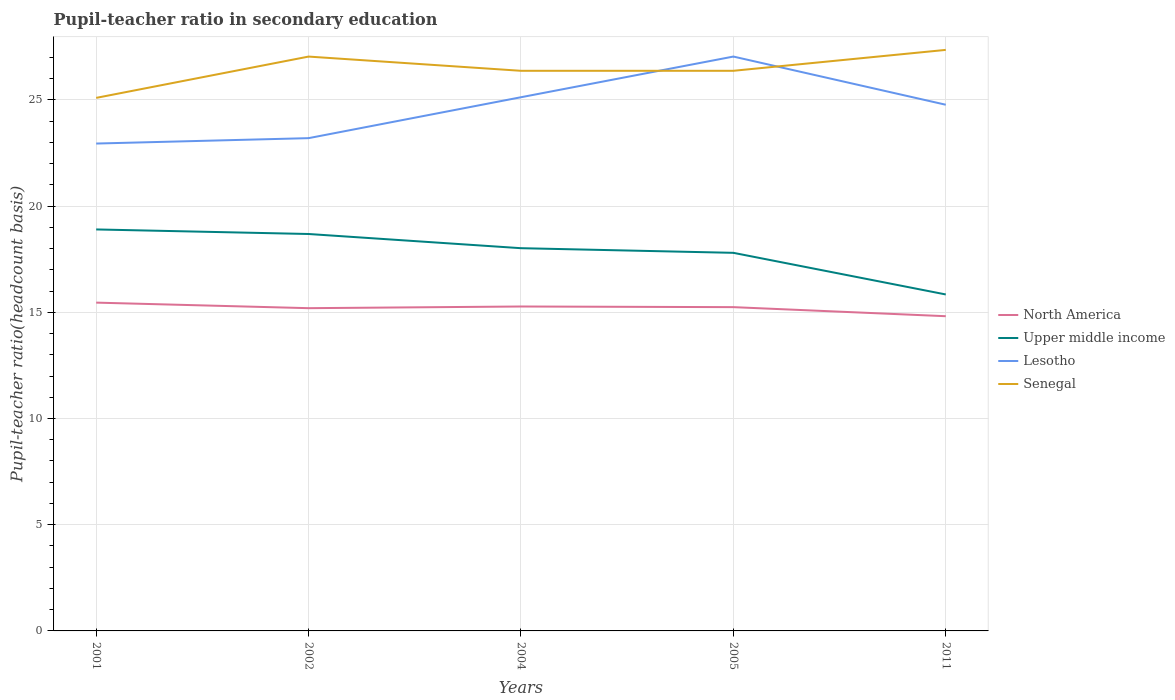How many different coloured lines are there?
Make the answer very short. 4. Is the number of lines equal to the number of legend labels?
Give a very brief answer. Yes. Across all years, what is the maximum pupil-teacher ratio in secondary education in Lesotho?
Provide a short and direct response. 22.94. What is the total pupil-teacher ratio in secondary education in Senegal in the graph?
Give a very brief answer. -0. What is the difference between the highest and the second highest pupil-teacher ratio in secondary education in North America?
Your answer should be compact. 0.64. Is the pupil-teacher ratio in secondary education in Upper middle income strictly greater than the pupil-teacher ratio in secondary education in North America over the years?
Ensure brevity in your answer.  No. How many lines are there?
Offer a terse response. 4. How many years are there in the graph?
Your answer should be very brief. 5. What is the difference between two consecutive major ticks on the Y-axis?
Keep it short and to the point. 5. Where does the legend appear in the graph?
Your answer should be very brief. Center right. What is the title of the graph?
Your response must be concise. Pupil-teacher ratio in secondary education. Does "Colombia" appear as one of the legend labels in the graph?
Keep it short and to the point. No. What is the label or title of the Y-axis?
Give a very brief answer. Pupil-teacher ratio(headcount basis). What is the Pupil-teacher ratio(headcount basis) of North America in 2001?
Provide a short and direct response. 15.45. What is the Pupil-teacher ratio(headcount basis) of Upper middle income in 2001?
Provide a short and direct response. 18.9. What is the Pupil-teacher ratio(headcount basis) of Lesotho in 2001?
Make the answer very short. 22.94. What is the Pupil-teacher ratio(headcount basis) of Senegal in 2001?
Your answer should be compact. 25.09. What is the Pupil-teacher ratio(headcount basis) in North America in 2002?
Your answer should be compact. 15.19. What is the Pupil-teacher ratio(headcount basis) of Upper middle income in 2002?
Provide a succinct answer. 18.68. What is the Pupil-teacher ratio(headcount basis) in Lesotho in 2002?
Keep it short and to the point. 23.2. What is the Pupil-teacher ratio(headcount basis) of Senegal in 2002?
Provide a succinct answer. 27.04. What is the Pupil-teacher ratio(headcount basis) in North America in 2004?
Your answer should be very brief. 15.27. What is the Pupil-teacher ratio(headcount basis) in Upper middle income in 2004?
Provide a succinct answer. 18.02. What is the Pupil-teacher ratio(headcount basis) of Lesotho in 2004?
Your response must be concise. 25.12. What is the Pupil-teacher ratio(headcount basis) of Senegal in 2004?
Your response must be concise. 26.37. What is the Pupil-teacher ratio(headcount basis) in North America in 2005?
Provide a short and direct response. 15.24. What is the Pupil-teacher ratio(headcount basis) in Upper middle income in 2005?
Provide a succinct answer. 17.8. What is the Pupil-teacher ratio(headcount basis) of Lesotho in 2005?
Provide a succinct answer. 27.04. What is the Pupil-teacher ratio(headcount basis) of Senegal in 2005?
Your response must be concise. 26.37. What is the Pupil-teacher ratio(headcount basis) in North America in 2011?
Your response must be concise. 14.81. What is the Pupil-teacher ratio(headcount basis) of Upper middle income in 2011?
Offer a terse response. 15.84. What is the Pupil-teacher ratio(headcount basis) of Lesotho in 2011?
Provide a short and direct response. 24.77. What is the Pupil-teacher ratio(headcount basis) in Senegal in 2011?
Offer a terse response. 27.35. Across all years, what is the maximum Pupil-teacher ratio(headcount basis) of North America?
Ensure brevity in your answer.  15.45. Across all years, what is the maximum Pupil-teacher ratio(headcount basis) of Upper middle income?
Your answer should be very brief. 18.9. Across all years, what is the maximum Pupil-teacher ratio(headcount basis) in Lesotho?
Offer a terse response. 27.04. Across all years, what is the maximum Pupil-teacher ratio(headcount basis) of Senegal?
Keep it short and to the point. 27.35. Across all years, what is the minimum Pupil-teacher ratio(headcount basis) in North America?
Keep it short and to the point. 14.81. Across all years, what is the minimum Pupil-teacher ratio(headcount basis) in Upper middle income?
Offer a very short reply. 15.84. Across all years, what is the minimum Pupil-teacher ratio(headcount basis) of Lesotho?
Make the answer very short. 22.94. Across all years, what is the minimum Pupil-teacher ratio(headcount basis) of Senegal?
Keep it short and to the point. 25.09. What is the total Pupil-teacher ratio(headcount basis) of North America in the graph?
Provide a succinct answer. 75.98. What is the total Pupil-teacher ratio(headcount basis) in Upper middle income in the graph?
Make the answer very short. 89.24. What is the total Pupil-teacher ratio(headcount basis) in Lesotho in the graph?
Your answer should be compact. 123.07. What is the total Pupil-teacher ratio(headcount basis) of Senegal in the graph?
Provide a short and direct response. 132.22. What is the difference between the Pupil-teacher ratio(headcount basis) in North America in 2001 and that in 2002?
Offer a terse response. 0.26. What is the difference between the Pupil-teacher ratio(headcount basis) of Upper middle income in 2001 and that in 2002?
Offer a terse response. 0.21. What is the difference between the Pupil-teacher ratio(headcount basis) of Lesotho in 2001 and that in 2002?
Offer a terse response. -0.25. What is the difference between the Pupil-teacher ratio(headcount basis) in Senegal in 2001 and that in 2002?
Your answer should be very brief. -1.94. What is the difference between the Pupil-teacher ratio(headcount basis) in North America in 2001 and that in 2004?
Keep it short and to the point. 0.18. What is the difference between the Pupil-teacher ratio(headcount basis) in Upper middle income in 2001 and that in 2004?
Provide a succinct answer. 0.88. What is the difference between the Pupil-teacher ratio(headcount basis) in Lesotho in 2001 and that in 2004?
Provide a succinct answer. -2.18. What is the difference between the Pupil-teacher ratio(headcount basis) of Senegal in 2001 and that in 2004?
Provide a succinct answer. -1.27. What is the difference between the Pupil-teacher ratio(headcount basis) in North America in 2001 and that in 2005?
Your answer should be compact. 0.21. What is the difference between the Pupil-teacher ratio(headcount basis) in Upper middle income in 2001 and that in 2005?
Make the answer very short. 1.1. What is the difference between the Pupil-teacher ratio(headcount basis) in Lesotho in 2001 and that in 2005?
Provide a short and direct response. -4.1. What is the difference between the Pupil-teacher ratio(headcount basis) of Senegal in 2001 and that in 2005?
Offer a very short reply. -1.27. What is the difference between the Pupil-teacher ratio(headcount basis) in North America in 2001 and that in 2011?
Keep it short and to the point. 0.64. What is the difference between the Pupil-teacher ratio(headcount basis) of Upper middle income in 2001 and that in 2011?
Your answer should be very brief. 3.06. What is the difference between the Pupil-teacher ratio(headcount basis) of Lesotho in 2001 and that in 2011?
Your answer should be very brief. -1.83. What is the difference between the Pupil-teacher ratio(headcount basis) of Senegal in 2001 and that in 2011?
Keep it short and to the point. -2.26. What is the difference between the Pupil-teacher ratio(headcount basis) of North America in 2002 and that in 2004?
Your response must be concise. -0.08. What is the difference between the Pupil-teacher ratio(headcount basis) in Upper middle income in 2002 and that in 2004?
Keep it short and to the point. 0.67. What is the difference between the Pupil-teacher ratio(headcount basis) in Lesotho in 2002 and that in 2004?
Keep it short and to the point. -1.93. What is the difference between the Pupil-teacher ratio(headcount basis) in Senegal in 2002 and that in 2004?
Keep it short and to the point. 0.67. What is the difference between the Pupil-teacher ratio(headcount basis) in North America in 2002 and that in 2005?
Offer a very short reply. -0.05. What is the difference between the Pupil-teacher ratio(headcount basis) of Upper middle income in 2002 and that in 2005?
Ensure brevity in your answer.  0.89. What is the difference between the Pupil-teacher ratio(headcount basis) in Lesotho in 2002 and that in 2005?
Your answer should be compact. -3.84. What is the difference between the Pupil-teacher ratio(headcount basis) in Senegal in 2002 and that in 2005?
Ensure brevity in your answer.  0.67. What is the difference between the Pupil-teacher ratio(headcount basis) of North America in 2002 and that in 2011?
Ensure brevity in your answer.  0.38. What is the difference between the Pupil-teacher ratio(headcount basis) in Upper middle income in 2002 and that in 2011?
Provide a succinct answer. 2.85. What is the difference between the Pupil-teacher ratio(headcount basis) of Lesotho in 2002 and that in 2011?
Offer a very short reply. -1.57. What is the difference between the Pupil-teacher ratio(headcount basis) in Senegal in 2002 and that in 2011?
Offer a very short reply. -0.32. What is the difference between the Pupil-teacher ratio(headcount basis) of North America in 2004 and that in 2005?
Ensure brevity in your answer.  0.03. What is the difference between the Pupil-teacher ratio(headcount basis) in Upper middle income in 2004 and that in 2005?
Offer a terse response. 0.22. What is the difference between the Pupil-teacher ratio(headcount basis) in Lesotho in 2004 and that in 2005?
Your answer should be very brief. -1.91. What is the difference between the Pupil-teacher ratio(headcount basis) in Senegal in 2004 and that in 2005?
Ensure brevity in your answer.  -0. What is the difference between the Pupil-teacher ratio(headcount basis) in North America in 2004 and that in 2011?
Your answer should be very brief. 0.46. What is the difference between the Pupil-teacher ratio(headcount basis) in Upper middle income in 2004 and that in 2011?
Your answer should be very brief. 2.18. What is the difference between the Pupil-teacher ratio(headcount basis) in Lesotho in 2004 and that in 2011?
Provide a succinct answer. 0.35. What is the difference between the Pupil-teacher ratio(headcount basis) in Senegal in 2004 and that in 2011?
Ensure brevity in your answer.  -0.98. What is the difference between the Pupil-teacher ratio(headcount basis) in North America in 2005 and that in 2011?
Your response must be concise. 0.43. What is the difference between the Pupil-teacher ratio(headcount basis) in Upper middle income in 2005 and that in 2011?
Make the answer very short. 1.96. What is the difference between the Pupil-teacher ratio(headcount basis) in Lesotho in 2005 and that in 2011?
Provide a short and direct response. 2.27. What is the difference between the Pupil-teacher ratio(headcount basis) in Senegal in 2005 and that in 2011?
Your answer should be very brief. -0.98. What is the difference between the Pupil-teacher ratio(headcount basis) of North America in 2001 and the Pupil-teacher ratio(headcount basis) of Upper middle income in 2002?
Your answer should be very brief. -3.23. What is the difference between the Pupil-teacher ratio(headcount basis) in North America in 2001 and the Pupil-teacher ratio(headcount basis) in Lesotho in 2002?
Your answer should be very brief. -7.74. What is the difference between the Pupil-teacher ratio(headcount basis) in North America in 2001 and the Pupil-teacher ratio(headcount basis) in Senegal in 2002?
Ensure brevity in your answer.  -11.58. What is the difference between the Pupil-teacher ratio(headcount basis) in Upper middle income in 2001 and the Pupil-teacher ratio(headcount basis) in Lesotho in 2002?
Provide a succinct answer. -4.3. What is the difference between the Pupil-teacher ratio(headcount basis) of Upper middle income in 2001 and the Pupil-teacher ratio(headcount basis) of Senegal in 2002?
Offer a terse response. -8.14. What is the difference between the Pupil-teacher ratio(headcount basis) in Lesotho in 2001 and the Pupil-teacher ratio(headcount basis) in Senegal in 2002?
Provide a succinct answer. -4.09. What is the difference between the Pupil-teacher ratio(headcount basis) in North America in 2001 and the Pupil-teacher ratio(headcount basis) in Upper middle income in 2004?
Your answer should be compact. -2.56. What is the difference between the Pupil-teacher ratio(headcount basis) in North America in 2001 and the Pupil-teacher ratio(headcount basis) in Lesotho in 2004?
Provide a succinct answer. -9.67. What is the difference between the Pupil-teacher ratio(headcount basis) in North America in 2001 and the Pupil-teacher ratio(headcount basis) in Senegal in 2004?
Offer a terse response. -10.91. What is the difference between the Pupil-teacher ratio(headcount basis) in Upper middle income in 2001 and the Pupil-teacher ratio(headcount basis) in Lesotho in 2004?
Your answer should be compact. -6.22. What is the difference between the Pupil-teacher ratio(headcount basis) in Upper middle income in 2001 and the Pupil-teacher ratio(headcount basis) in Senegal in 2004?
Provide a short and direct response. -7.47. What is the difference between the Pupil-teacher ratio(headcount basis) of Lesotho in 2001 and the Pupil-teacher ratio(headcount basis) of Senegal in 2004?
Make the answer very short. -3.42. What is the difference between the Pupil-teacher ratio(headcount basis) of North America in 2001 and the Pupil-teacher ratio(headcount basis) of Upper middle income in 2005?
Your answer should be very brief. -2.34. What is the difference between the Pupil-teacher ratio(headcount basis) of North America in 2001 and the Pupil-teacher ratio(headcount basis) of Lesotho in 2005?
Your answer should be compact. -11.58. What is the difference between the Pupil-teacher ratio(headcount basis) of North America in 2001 and the Pupil-teacher ratio(headcount basis) of Senegal in 2005?
Ensure brevity in your answer.  -10.91. What is the difference between the Pupil-teacher ratio(headcount basis) of Upper middle income in 2001 and the Pupil-teacher ratio(headcount basis) of Lesotho in 2005?
Your answer should be compact. -8.14. What is the difference between the Pupil-teacher ratio(headcount basis) of Upper middle income in 2001 and the Pupil-teacher ratio(headcount basis) of Senegal in 2005?
Make the answer very short. -7.47. What is the difference between the Pupil-teacher ratio(headcount basis) in Lesotho in 2001 and the Pupil-teacher ratio(headcount basis) in Senegal in 2005?
Your response must be concise. -3.42. What is the difference between the Pupil-teacher ratio(headcount basis) of North America in 2001 and the Pupil-teacher ratio(headcount basis) of Upper middle income in 2011?
Provide a succinct answer. -0.38. What is the difference between the Pupil-teacher ratio(headcount basis) in North America in 2001 and the Pupil-teacher ratio(headcount basis) in Lesotho in 2011?
Give a very brief answer. -9.31. What is the difference between the Pupil-teacher ratio(headcount basis) of North America in 2001 and the Pupil-teacher ratio(headcount basis) of Senegal in 2011?
Keep it short and to the point. -11.9. What is the difference between the Pupil-teacher ratio(headcount basis) in Upper middle income in 2001 and the Pupil-teacher ratio(headcount basis) in Lesotho in 2011?
Keep it short and to the point. -5.87. What is the difference between the Pupil-teacher ratio(headcount basis) of Upper middle income in 2001 and the Pupil-teacher ratio(headcount basis) of Senegal in 2011?
Offer a terse response. -8.45. What is the difference between the Pupil-teacher ratio(headcount basis) in Lesotho in 2001 and the Pupil-teacher ratio(headcount basis) in Senegal in 2011?
Ensure brevity in your answer.  -4.41. What is the difference between the Pupil-teacher ratio(headcount basis) of North America in 2002 and the Pupil-teacher ratio(headcount basis) of Upper middle income in 2004?
Make the answer very short. -2.82. What is the difference between the Pupil-teacher ratio(headcount basis) in North America in 2002 and the Pupil-teacher ratio(headcount basis) in Lesotho in 2004?
Your response must be concise. -9.93. What is the difference between the Pupil-teacher ratio(headcount basis) in North America in 2002 and the Pupil-teacher ratio(headcount basis) in Senegal in 2004?
Your answer should be compact. -11.17. What is the difference between the Pupil-teacher ratio(headcount basis) of Upper middle income in 2002 and the Pupil-teacher ratio(headcount basis) of Lesotho in 2004?
Provide a succinct answer. -6.44. What is the difference between the Pupil-teacher ratio(headcount basis) in Upper middle income in 2002 and the Pupil-teacher ratio(headcount basis) in Senegal in 2004?
Offer a terse response. -7.68. What is the difference between the Pupil-teacher ratio(headcount basis) of Lesotho in 2002 and the Pupil-teacher ratio(headcount basis) of Senegal in 2004?
Provide a short and direct response. -3.17. What is the difference between the Pupil-teacher ratio(headcount basis) in North America in 2002 and the Pupil-teacher ratio(headcount basis) in Upper middle income in 2005?
Make the answer very short. -2.61. What is the difference between the Pupil-teacher ratio(headcount basis) in North America in 2002 and the Pupil-teacher ratio(headcount basis) in Lesotho in 2005?
Your answer should be very brief. -11.84. What is the difference between the Pupil-teacher ratio(headcount basis) in North America in 2002 and the Pupil-teacher ratio(headcount basis) in Senegal in 2005?
Ensure brevity in your answer.  -11.17. What is the difference between the Pupil-teacher ratio(headcount basis) in Upper middle income in 2002 and the Pupil-teacher ratio(headcount basis) in Lesotho in 2005?
Make the answer very short. -8.35. What is the difference between the Pupil-teacher ratio(headcount basis) in Upper middle income in 2002 and the Pupil-teacher ratio(headcount basis) in Senegal in 2005?
Offer a very short reply. -7.68. What is the difference between the Pupil-teacher ratio(headcount basis) in Lesotho in 2002 and the Pupil-teacher ratio(headcount basis) in Senegal in 2005?
Ensure brevity in your answer.  -3.17. What is the difference between the Pupil-teacher ratio(headcount basis) in North America in 2002 and the Pupil-teacher ratio(headcount basis) in Upper middle income in 2011?
Ensure brevity in your answer.  -0.65. What is the difference between the Pupil-teacher ratio(headcount basis) in North America in 2002 and the Pupil-teacher ratio(headcount basis) in Lesotho in 2011?
Ensure brevity in your answer.  -9.58. What is the difference between the Pupil-teacher ratio(headcount basis) in North America in 2002 and the Pupil-teacher ratio(headcount basis) in Senegal in 2011?
Your answer should be very brief. -12.16. What is the difference between the Pupil-teacher ratio(headcount basis) in Upper middle income in 2002 and the Pupil-teacher ratio(headcount basis) in Lesotho in 2011?
Your response must be concise. -6.08. What is the difference between the Pupil-teacher ratio(headcount basis) in Upper middle income in 2002 and the Pupil-teacher ratio(headcount basis) in Senegal in 2011?
Provide a succinct answer. -8.67. What is the difference between the Pupil-teacher ratio(headcount basis) in Lesotho in 2002 and the Pupil-teacher ratio(headcount basis) in Senegal in 2011?
Ensure brevity in your answer.  -4.15. What is the difference between the Pupil-teacher ratio(headcount basis) in North America in 2004 and the Pupil-teacher ratio(headcount basis) in Upper middle income in 2005?
Keep it short and to the point. -2.53. What is the difference between the Pupil-teacher ratio(headcount basis) in North America in 2004 and the Pupil-teacher ratio(headcount basis) in Lesotho in 2005?
Your answer should be very brief. -11.77. What is the difference between the Pupil-teacher ratio(headcount basis) of North America in 2004 and the Pupil-teacher ratio(headcount basis) of Senegal in 2005?
Keep it short and to the point. -11.1. What is the difference between the Pupil-teacher ratio(headcount basis) of Upper middle income in 2004 and the Pupil-teacher ratio(headcount basis) of Lesotho in 2005?
Your answer should be very brief. -9.02. What is the difference between the Pupil-teacher ratio(headcount basis) in Upper middle income in 2004 and the Pupil-teacher ratio(headcount basis) in Senegal in 2005?
Ensure brevity in your answer.  -8.35. What is the difference between the Pupil-teacher ratio(headcount basis) of Lesotho in 2004 and the Pupil-teacher ratio(headcount basis) of Senegal in 2005?
Offer a terse response. -1.24. What is the difference between the Pupil-teacher ratio(headcount basis) of North America in 2004 and the Pupil-teacher ratio(headcount basis) of Upper middle income in 2011?
Ensure brevity in your answer.  -0.57. What is the difference between the Pupil-teacher ratio(headcount basis) of North America in 2004 and the Pupil-teacher ratio(headcount basis) of Lesotho in 2011?
Give a very brief answer. -9.5. What is the difference between the Pupil-teacher ratio(headcount basis) in North America in 2004 and the Pupil-teacher ratio(headcount basis) in Senegal in 2011?
Provide a succinct answer. -12.08. What is the difference between the Pupil-teacher ratio(headcount basis) of Upper middle income in 2004 and the Pupil-teacher ratio(headcount basis) of Lesotho in 2011?
Give a very brief answer. -6.75. What is the difference between the Pupil-teacher ratio(headcount basis) in Upper middle income in 2004 and the Pupil-teacher ratio(headcount basis) in Senegal in 2011?
Ensure brevity in your answer.  -9.34. What is the difference between the Pupil-teacher ratio(headcount basis) of Lesotho in 2004 and the Pupil-teacher ratio(headcount basis) of Senegal in 2011?
Offer a terse response. -2.23. What is the difference between the Pupil-teacher ratio(headcount basis) in North America in 2005 and the Pupil-teacher ratio(headcount basis) in Upper middle income in 2011?
Your answer should be very brief. -0.6. What is the difference between the Pupil-teacher ratio(headcount basis) in North America in 2005 and the Pupil-teacher ratio(headcount basis) in Lesotho in 2011?
Your answer should be compact. -9.53. What is the difference between the Pupil-teacher ratio(headcount basis) of North America in 2005 and the Pupil-teacher ratio(headcount basis) of Senegal in 2011?
Offer a terse response. -12.11. What is the difference between the Pupil-teacher ratio(headcount basis) in Upper middle income in 2005 and the Pupil-teacher ratio(headcount basis) in Lesotho in 2011?
Give a very brief answer. -6.97. What is the difference between the Pupil-teacher ratio(headcount basis) of Upper middle income in 2005 and the Pupil-teacher ratio(headcount basis) of Senegal in 2011?
Your answer should be compact. -9.55. What is the difference between the Pupil-teacher ratio(headcount basis) of Lesotho in 2005 and the Pupil-teacher ratio(headcount basis) of Senegal in 2011?
Keep it short and to the point. -0.31. What is the average Pupil-teacher ratio(headcount basis) in North America per year?
Keep it short and to the point. 15.2. What is the average Pupil-teacher ratio(headcount basis) in Upper middle income per year?
Ensure brevity in your answer.  17.85. What is the average Pupil-teacher ratio(headcount basis) of Lesotho per year?
Provide a succinct answer. 24.61. What is the average Pupil-teacher ratio(headcount basis) of Senegal per year?
Keep it short and to the point. 26.44. In the year 2001, what is the difference between the Pupil-teacher ratio(headcount basis) in North America and Pupil-teacher ratio(headcount basis) in Upper middle income?
Your answer should be very brief. -3.45. In the year 2001, what is the difference between the Pupil-teacher ratio(headcount basis) in North America and Pupil-teacher ratio(headcount basis) in Lesotho?
Your answer should be compact. -7.49. In the year 2001, what is the difference between the Pupil-teacher ratio(headcount basis) of North America and Pupil-teacher ratio(headcount basis) of Senegal?
Your response must be concise. -9.64. In the year 2001, what is the difference between the Pupil-teacher ratio(headcount basis) in Upper middle income and Pupil-teacher ratio(headcount basis) in Lesotho?
Your answer should be compact. -4.04. In the year 2001, what is the difference between the Pupil-teacher ratio(headcount basis) of Upper middle income and Pupil-teacher ratio(headcount basis) of Senegal?
Your answer should be compact. -6.19. In the year 2001, what is the difference between the Pupil-teacher ratio(headcount basis) of Lesotho and Pupil-teacher ratio(headcount basis) of Senegal?
Ensure brevity in your answer.  -2.15. In the year 2002, what is the difference between the Pupil-teacher ratio(headcount basis) in North America and Pupil-teacher ratio(headcount basis) in Upper middle income?
Your answer should be very brief. -3.49. In the year 2002, what is the difference between the Pupil-teacher ratio(headcount basis) in North America and Pupil-teacher ratio(headcount basis) in Lesotho?
Provide a succinct answer. -8. In the year 2002, what is the difference between the Pupil-teacher ratio(headcount basis) of North America and Pupil-teacher ratio(headcount basis) of Senegal?
Your response must be concise. -11.84. In the year 2002, what is the difference between the Pupil-teacher ratio(headcount basis) of Upper middle income and Pupil-teacher ratio(headcount basis) of Lesotho?
Provide a short and direct response. -4.51. In the year 2002, what is the difference between the Pupil-teacher ratio(headcount basis) of Upper middle income and Pupil-teacher ratio(headcount basis) of Senegal?
Offer a terse response. -8.35. In the year 2002, what is the difference between the Pupil-teacher ratio(headcount basis) of Lesotho and Pupil-teacher ratio(headcount basis) of Senegal?
Give a very brief answer. -3.84. In the year 2004, what is the difference between the Pupil-teacher ratio(headcount basis) of North America and Pupil-teacher ratio(headcount basis) of Upper middle income?
Give a very brief answer. -2.74. In the year 2004, what is the difference between the Pupil-teacher ratio(headcount basis) of North America and Pupil-teacher ratio(headcount basis) of Lesotho?
Make the answer very short. -9.85. In the year 2004, what is the difference between the Pupil-teacher ratio(headcount basis) of North America and Pupil-teacher ratio(headcount basis) of Senegal?
Provide a succinct answer. -11.1. In the year 2004, what is the difference between the Pupil-teacher ratio(headcount basis) of Upper middle income and Pupil-teacher ratio(headcount basis) of Lesotho?
Make the answer very short. -7.11. In the year 2004, what is the difference between the Pupil-teacher ratio(headcount basis) of Upper middle income and Pupil-teacher ratio(headcount basis) of Senegal?
Keep it short and to the point. -8.35. In the year 2004, what is the difference between the Pupil-teacher ratio(headcount basis) of Lesotho and Pupil-teacher ratio(headcount basis) of Senegal?
Keep it short and to the point. -1.24. In the year 2005, what is the difference between the Pupil-teacher ratio(headcount basis) of North America and Pupil-teacher ratio(headcount basis) of Upper middle income?
Offer a terse response. -2.56. In the year 2005, what is the difference between the Pupil-teacher ratio(headcount basis) in North America and Pupil-teacher ratio(headcount basis) in Lesotho?
Ensure brevity in your answer.  -11.8. In the year 2005, what is the difference between the Pupil-teacher ratio(headcount basis) in North America and Pupil-teacher ratio(headcount basis) in Senegal?
Provide a short and direct response. -11.13. In the year 2005, what is the difference between the Pupil-teacher ratio(headcount basis) in Upper middle income and Pupil-teacher ratio(headcount basis) in Lesotho?
Make the answer very short. -9.24. In the year 2005, what is the difference between the Pupil-teacher ratio(headcount basis) of Upper middle income and Pupil-teacher ratio(headcount basis) of Senegal?
Offer a terse response. -8.57. In the year 2005, what is the difference between the Pupil-teacher ratio(headcount basis) in Lesotho and Pupil-teacher ratio(headcount basis) in Senegal?
Make the answer very short. 0.67. In the year 2011, what is the difference between the Pupil-teacher ratio(headcount basis) of North America and Pupil-teacher ratio(headcount basis) of Upper middle income?
Make the answer very short. -1.02. In the year 2011, what is the difference between the Pupil-teacher ratio(headcount basis) in North America and Pupil-teacher ratio(headcount basis) in Lesotho?
Offer a terse response. -9.95. In the year 2011, what is the difference between the Pupil-teacher ratio(headcount basis) in North America and Pupil-teacher ratio(headcount basis) in Senegal?
Make the answer very short. -12.54. In the year 2011, what is the difference between the Pupil-teacher ratio(headcount basis) in Upper middle income and Pupil-teacher ratio(headcount basis) in Lesotho?
Your response must be concise. -8.93. In the year 2011, what is the difference between the Pupil-teacher ratio(headcount basis) in Upper middle income and Pupil-teacher ratio(headcount basis) in Senegal?
Keep it short and to the point. -11.51. In the year 2011, what is the difference between the Pupil-teacher ratio(headcount basis) in Lesotho and Pupil-teacher ratio(headcount basis) in Senegal?
Provide a succinct answer. -2.58. What is the ratio of the Pupil-teacher ratio(headcount basis) of North America in 2001 to that in 2002?
Your answer should be compact. 1.02. What is the ratio of the Pupil-teacher ratio(headcount basis) of Upper middle income in 2001 to that in 2002?
Your response must be concise. 1.01. What is the ratio of the Pupil-teacher ratio(headcount basis) of Senegal in 2001 to that in 2002?
Your answer should be compact. 0.93. What is the ratio of the Pupil-teacher ratio(headcount basis) in North America in 2001 to that in 2004?
Ensure brevity in your answer.  1.01. What is the ratio of the Pupil-teacher ratio(headcount basis) of Upper middle income in 2001 to that in 2004?
Your answer should be very brief. 1.05. What is the ratio of the Pupil-teacher ratio(headcount basis) of Lesotho in 2001 to that in 2004?
Offer a terse response. 0.91. What is the ratio of the Pupil-teacher ratio(headcount basis) of Senegal in 2001 to that in 2004?
Give a very brief answer. 0.95. What is the ratio of the Pupil-teacher ratio(headcount basis) of North America in 2001 to that in 2005?
Offer a terse response. 1.01. What is the ratio of the Pupil-teacher ratio(headcount basis) of Upper middle income in 2001 to that in 2005?
Your response must be concise. 1.06. What is the ratio of the Pupil-teacher ratio(headcount basis) in Lesotho in 2001 to that in 2005?
Ensure brevity in your answer.  0.85. What is the ratio of the Pupil-teacher ratio(headcount basis) of Senegal in 2001 to that in 2005?
Keep it short and to the point. 0.95. What is the ratio of the Pupil-teacher ratio(headcount basis) in North America in 2001 to that in 2011?
Your response must be concise. 1.04. What is the ratio of the Pupil-teacher ratio(headcount basis) of Upper middle income in 2001 to that in 2011?
Your answer should be very brief. 1.19. What is the ratio of the Pupil-teacher ratio(headcount basis) of Lesotho in 2001 to that in 2011?
Give a very brief answer. 0.93. What is the ratio of the Pupil-teacher ratio(headcount basis) of Senegal in 2001 to that in 2011?
Offer a very short reply. 0.92. What is the ratio of the Pupil-teacher ratio(headcount basis) of North America in 2002 to that in 2004?
Make the answer very short. 0.99. What is the ratio of the Pupil-teacher ratio(headcount basis) in Upper middle income in 2002 to that in 2004?
Your answer should be very brief. 1.04. What is the ratio of the Pupil-teacher ratio(headcount basis) of Lesotho in 2002 to that in 2004?
Your answer should be very brief. 0.92. What is the ratio of the Pupil-teacher ratio(headcount basis) in Senegal in 2002 to that in 2004?
Make the answer very short. 1.03. What is the ratio of the Pupil-teacher ratio(headcount basis) in North America in 2002 to that in 2005?
Your answer should be very brief. 1. What is the ratio of the Pupil-teacher ratio(headcount basis) in Upper middle income in 2002 to that in 2005?
Provide a succinct answer. 1.05. What is the ratio of the Pupil-teacher ratio(headcount basis) of Lesotho in 2002 to that in 2005?
Provide a succinct answer. 0.86. What is the ratio of the Pupil-teacher ratio(headcount basis) in Senegal in 2002 to that in 2005?
Make the answer very short. 1.03. What is the ratio of the Pupil-teacher ratio(headcount basis) of North America in 2002 to that in 2011?
Give a very brief answer. 1.03. What is the ratio of the Pupil-teacher ratio(headcount basis) of Upper middle income in 2002 to that in 2011?
Give a very brief answer. 1.18. What is the ratio of the Pupil-teacher ratio(headcount basis) of Lesotho in 2002 to that in 2011?
Your response must be concise. 0.94. What is the ratio of the Pupil-teacher ratio(headcount basis) of Senegal in 2002 to that in 2011?
Ensure brevity in your answer.  0.99. What is the ratio of the Pupil-teacher ratio(headcount basis) in Upper middle income in 2004 to that in 2005?
Your answer should be compact. 1.01. What is the ratio of the Pupil-teacher ratio(headcount basis) in Lesotho in 2004 to that in 2005?
Offer a terse response. 0.93. What is the ratio of the Pupil-teacher ratio(headcount basis) of North America in 2004 to that in 2011?
Give a very brief answer. 1.03. What is the ratio of the Pupil-teacher ratio(headcount basis) in Upper middle income in 2004 to that in 2011?
Your response must be concise. 1.14. What is the ratio of the Pupil-teacher ratio(headcount basis) in Lesotho in 2004 to that in 2011?
Your answer should be very brief. 1.01. What is the ratio of the Pupil-teacher ratio(headcount basis) in North America in 2005 to that in 2011?
Provide a short and direct response. 1.03. What is the ratio of the Pupil-teacher ratio(headcount basis) of Upper middle income in 2005 to that in 2011?
Give a very brief answer. 1.12. What is the ratio of the Pupil-teacher ratio(headcount basis) in Lesotho in 2005 to that in 2011?
Your answer should be very brief. 1.09. What is the ratio of the Pupil-teacher ratio(headcount basis) of Senegal in 2005 to that in 2011?
Provide a succinct answer. 0.96. What is the difference between the highest and the second highest Pupil-teacher ratio(headcount basis) of North America?
Make the answer very short. 0.18. What is the difference between the highest and the second highest Pupil-teacher ratio(headcount basis) of Upper middle income?
Your response must be concise. 0.21. What is the difference between the highest and the second highest Pupil-teacher ratio(headcount basis) of Lesotho?
Provide a succinct answer. 1.91. What is the difference between the highest and the second highest Pupil-teacher ratio(headcount basis) in Senegal?
Offer a very short reply. 0.32. What is the difference between the highest and the lowest Pupil-teacher ratio(headcount basis) of North America?
Ensure brevity in your answer.  0.64. What is the difference between the highest and the lowest Pupil-teacher ratio(headcount basis) in Upper middle income?
Make the answer very short. 3.06. What is the difference between the highest and the lowest Pupil-teacher ratio(headcount basis) in Lesotho?
Offer a very short reply. 4.1. What is the difference between the highest and the lowest Pupil-teacher ratio(headcount basis) of Senegal?
Keep it short and to the point. 2.26. 